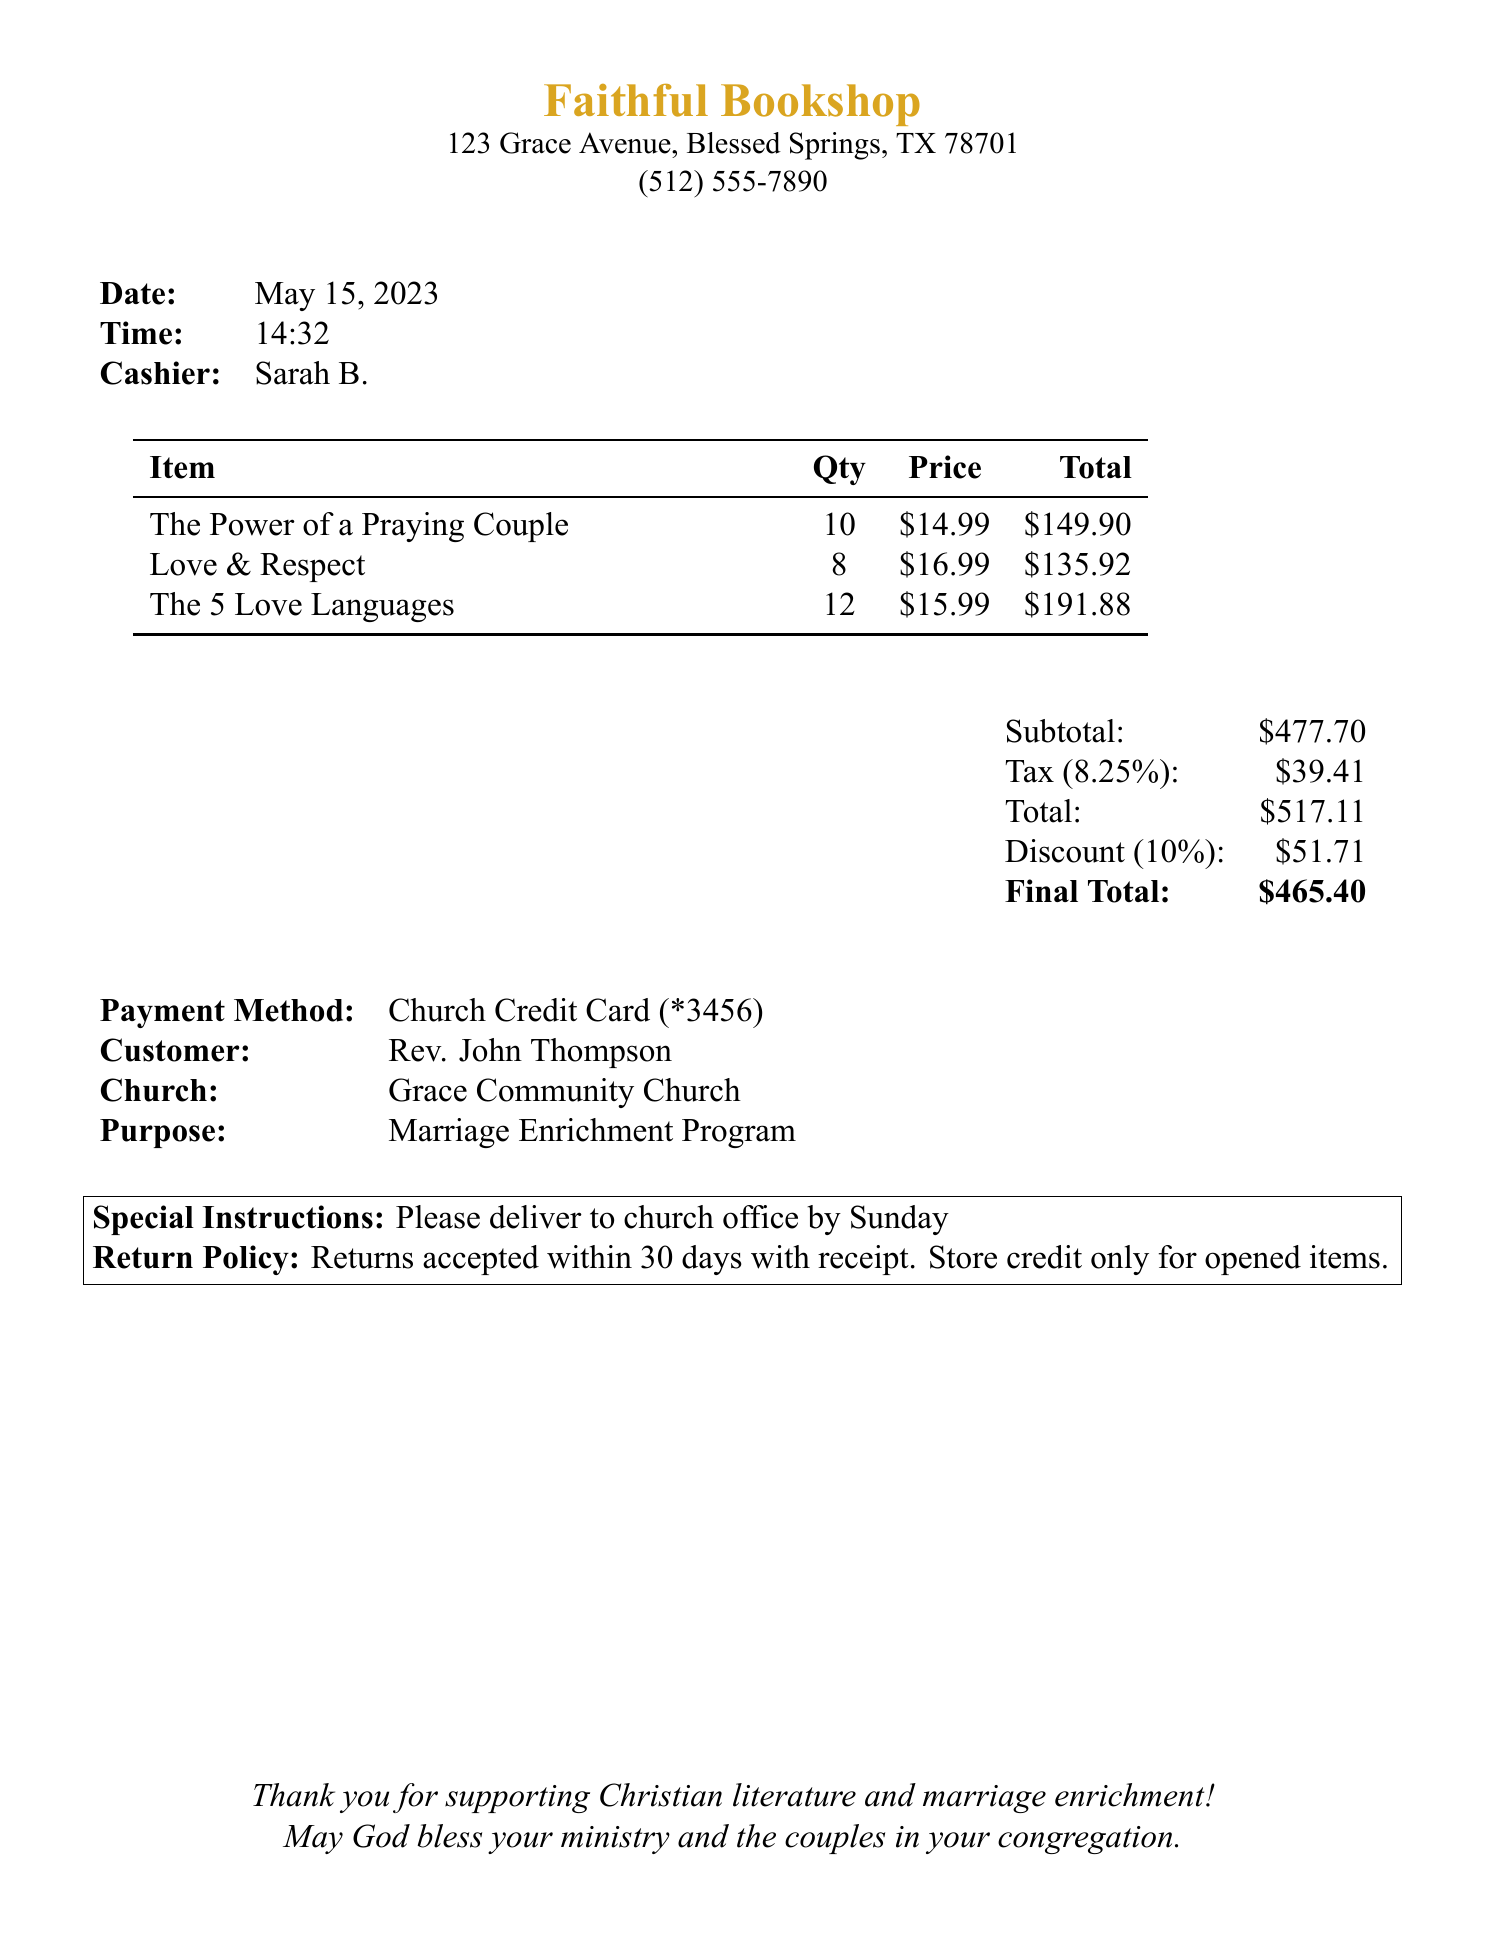What is the name of the bookstore? The bookstore's name is provided prominently at the top of the receipt.
Answer: Faithful Bookshop What was the total amount paid? The total amount is listed at the bottom of the receipt, specifying the final amount after discounts and taxes.
Answer: $465.40 Who is the author of "The Power of a Praying Couple"? The author of the title is stated next to the book name in the itemized list.
Answer: Stormie Omartian How many copies of "Love & Respect" were purchased? The quantity is noted in the itemized list next to the book title.
Answer: 8 What was the tax amount applied? The tax amount is presented as a separate line item before the total.
Answer: $39.41 What discount percentage was applied to the order? The discount percentage is specified alongside the discount amount.
Answer: 10% What is the address of the bookstore? The address is listed just below the store name.
Answer: 123 Grace Avenue, Blessed Springs, TX 78701 What payment method was used for the purchase? The payment method is clearly stated in the payment details section.
Answer: Church Credit Card What was the order purpose? The purpose for which the items were purchased is provided in the document.
Answer: Marriage Enrichment Program 